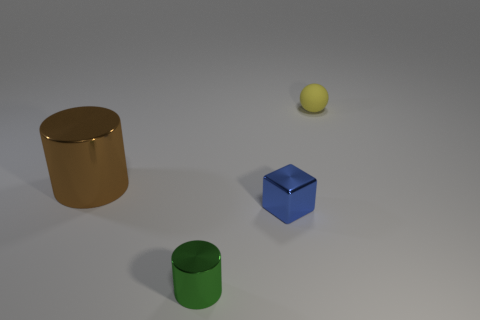Add 1 rubber cylinders. How many objects exist? 5 Subtract all brown cylinders. How many cylinders are left? 1 Subtract 1 balls. How many balls are left? 0 Add 2 tiny purple rubber blocks. How many tiny purple rubber blocks exist? 2 Subtract 0 red spheres. How many objects are left? 4 Subtract all spheres. How many objects are left? 3 Subtract all gray balls. Subtract all blue cylinders. How many balls are left? 1 Subtract all blue cubes. How many gray cylinders are left? 0 Subtract all large gray metal cylinders. Subtract all tiny green metal cylinders. How many objects are left? 3 Add 4 metallic cubes. How many metallic cubes are left? 5 